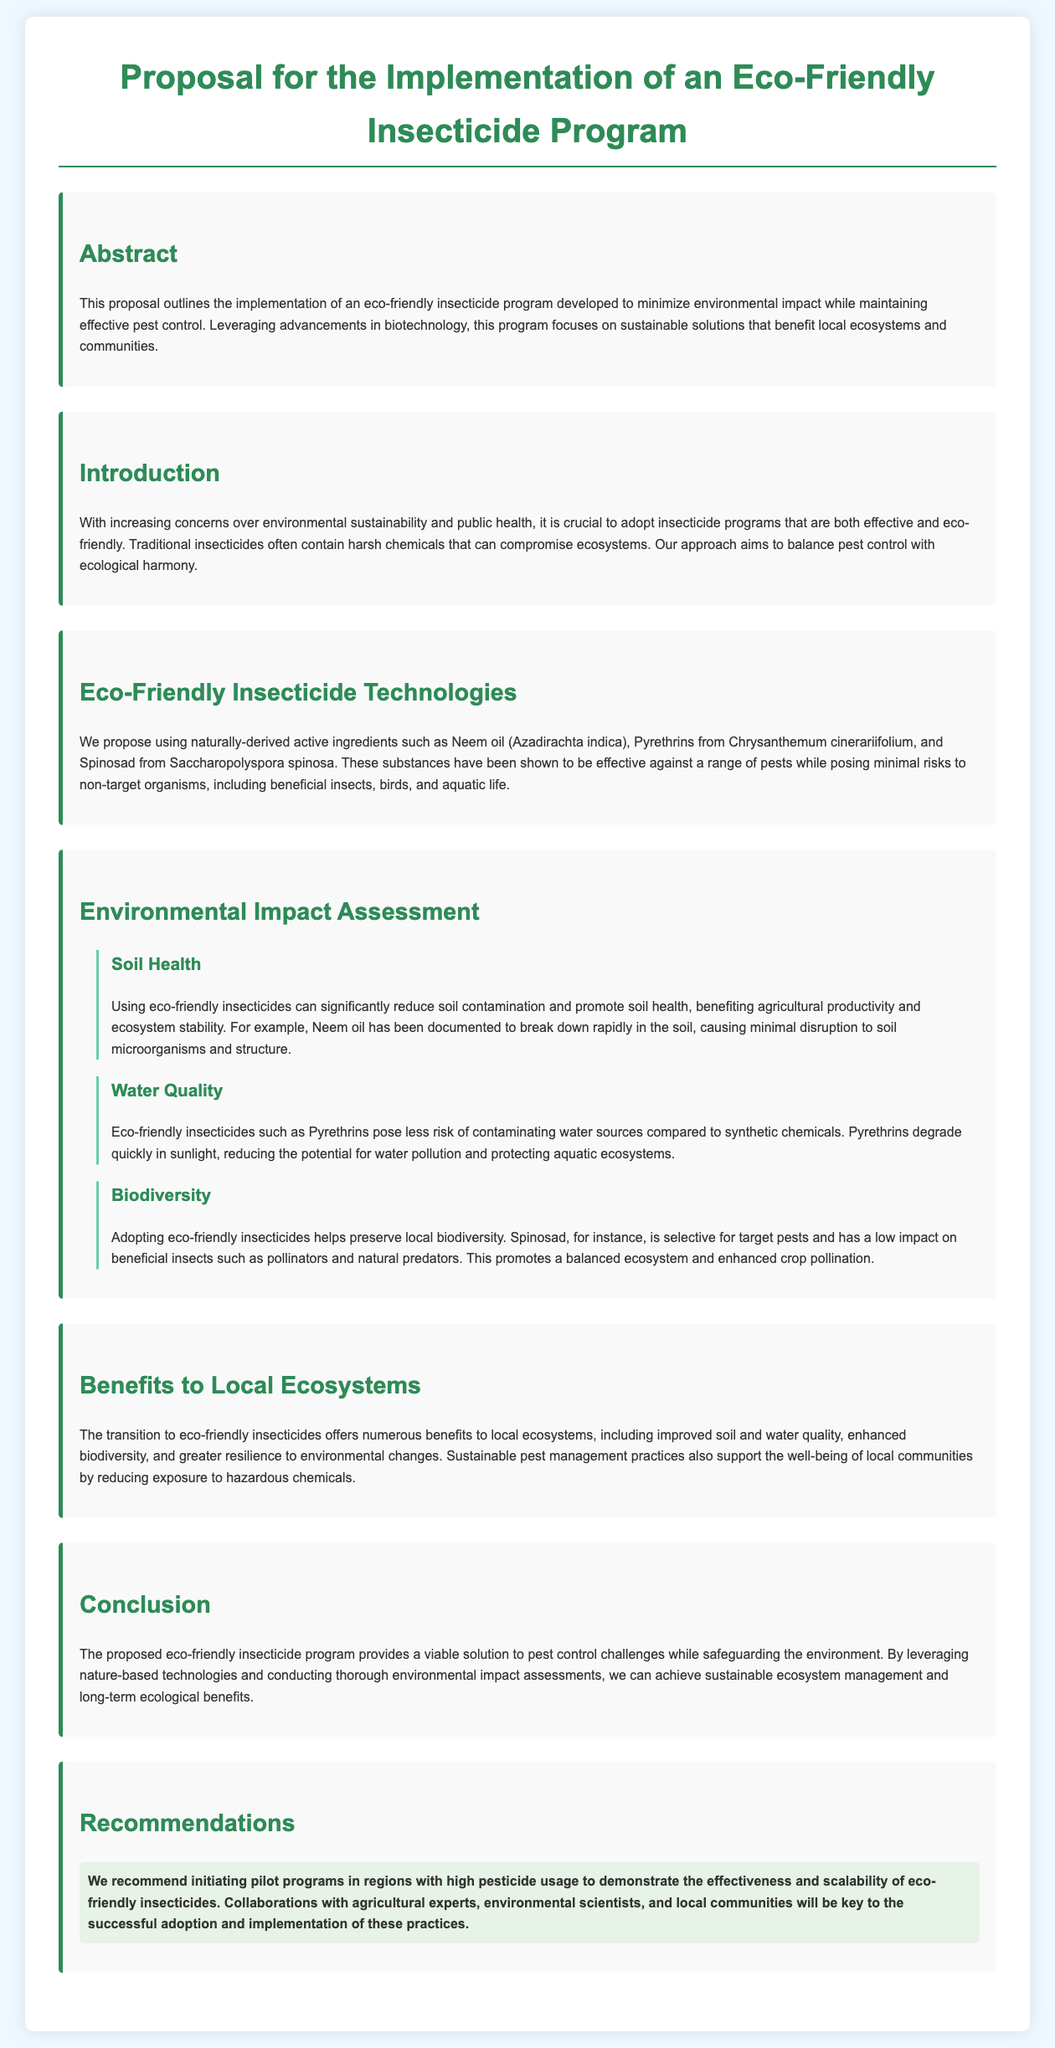What are the active ingredients proposed in the eco-friendly insecticide program? The document lists various naturally-derived active ingredients that will be used in the program.
Answer: Neem oil, Pyrethrins, Spinosad What is the main goal of the eco-friendly insecticide program? The main goal is mentioned in the abstract and introduction sections of the proposal.
Answer: Minimize environmental impact What is one benefit of using Neem oil in agriculture? The document explains the effects of Neem oil on soil health and microorganism activity.
Answer: Breaks down rapidly Which insecticide is highlighted for its quick degradation in sunlight? In the water quality subsection, a specific insecticide's property regarding degradation is mentioned.
Answer: Pyrethrins What is emphasized as crucial for the successful adoption of eco-friendly insecticides? The recommendations section outlines key factors for implementing the proposed program.
Answer: Collaborations with experts How do eco-friendly insecticides impact biodiversity, according to the document? The biodiversity subsection discusses their effects on beneficial insects and ecosystem balance.
Answer: Preserves local biodiversity What type of programs does the proposal recommend as a first step? The recommendations section mentions the nature of programs to demonstrate effectiveness.
Answer: Pilot programs What are the benefits of adopting eco-friendly insecticides mentioned in the proposal? The document outlines multiple benefits under the local ecosystems section.
Answer: Improved soil and water quality, enhanced biodiversity What is the purpose of conducting environmental impact assessments? The introduction and later sections of the proposal explain the role of assessments in the program.
Answer: Ensure sustainable ecosystem management 